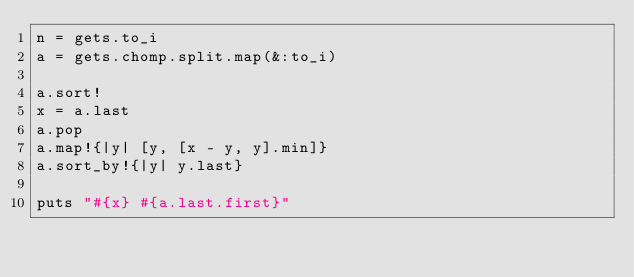Convert code to text. <code><loc_0><loc_0><loc_500><loc_500><_Ruby_>n = gets.to_i
a = gets.chomp.split.map(&:to_i)

a.sort!
x = a.last
a.pop
a.map!{|y| [y, [x - y, y].min]}
a.sort_by!{|y| y.last}

puts "#{x} #{a.last.first}"</code> 